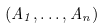<formula> <loc_0><loc_0><loc_500><loc_500>( A _ { 1 } , \dots , A _ { n } )</formula> 